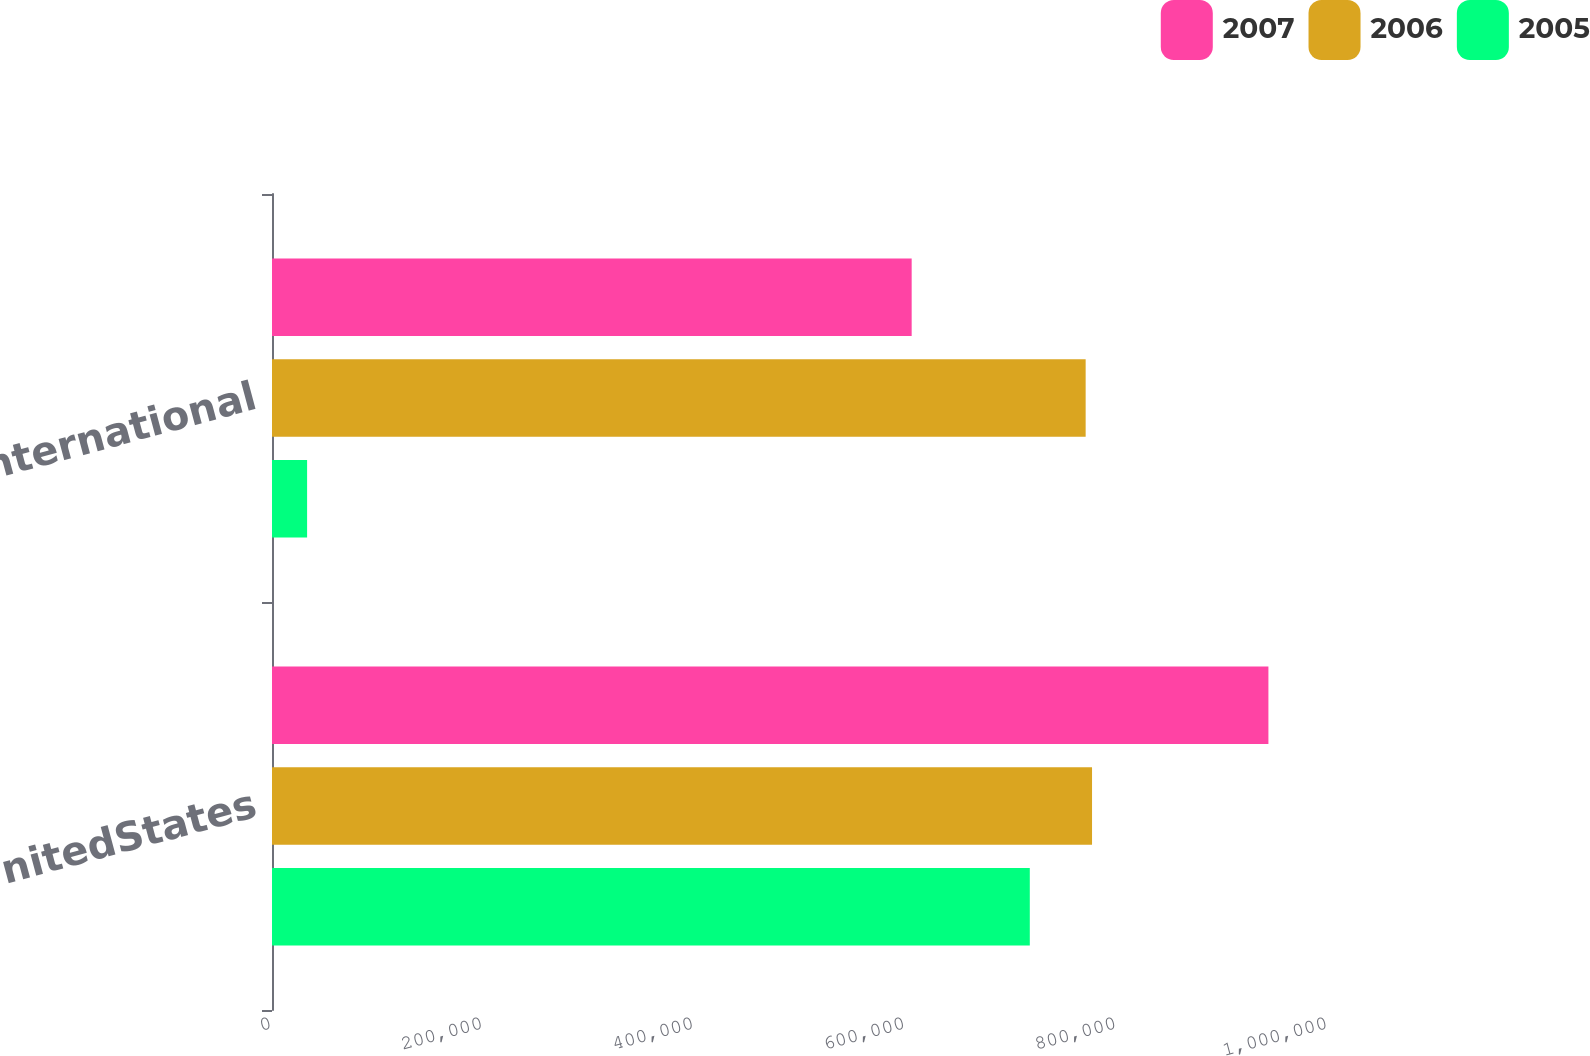Convert chart. <chart><loc_0><loc_0><loc_500><loc_500><stacked_bar_chart><ecel><fcel>UnitedStates<fcel>International<nl><fcel>2007<fcel>943575<fcel>605753<nl><fcel>2006<fcel>776553<fcel>770504<nl><fcel>2005<fcel>717614<fcel>33237<nl></chart> 